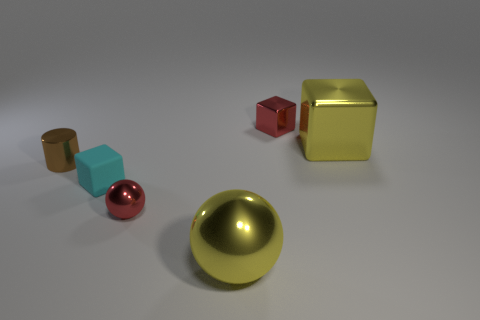Add 1 red metallic spheres. How many objects exist? 7 Subtract all balls. How many objects are left? 4 Subtract 0 gray cylinders. How many objects are left? 6 Subtract all big gray matte things. Subtract all metallic blocks. How many objects are left? 4 Add 3 spheres. How many spheres are left? 5 Add 2 cyan cubes. How many cyan cubes exist? 3 